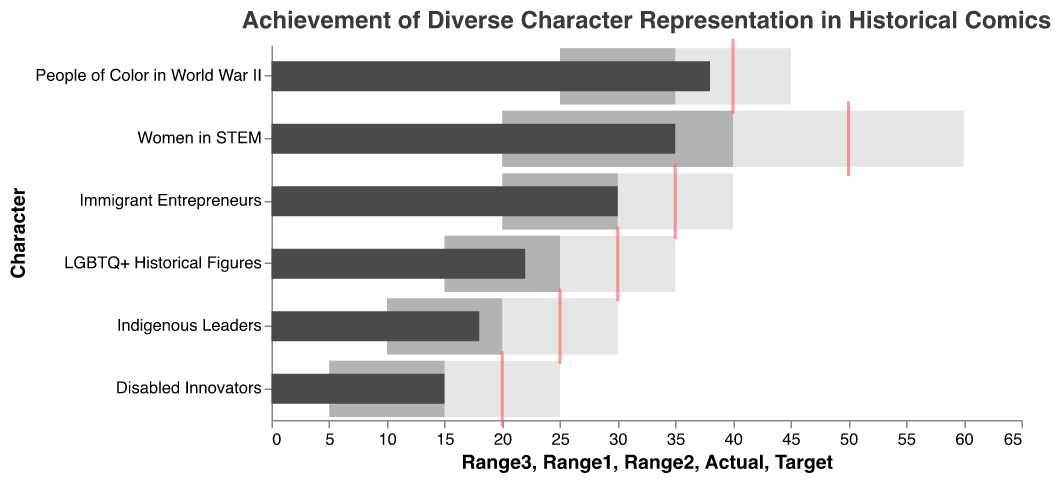What is the actual representation of 'Women in STEM' characters? The actual value for 'Women in STEM' can be seen in the bar marked dark gray. It shows a value of 35.
Answer: 35 How much lower is the actual representation of 'LGBTQ+ Historical Figures' compared to the target? The actual value for 'LGBTQ+ Historical Figures' is 22, while the target is 30. The difference is 30 - 22 = 8.
Answer: 8 Which character category meets its target closest? By looking at the bars and the tick marks for targets, 'People of Color in World War II' has the actual value of 38 very close to the target of 40, more so than the other categories.
Answer: People of Color in World War II What is the title of the chart? The title appears at the top of the chart and it reads: "Achievement of Diverse Character Representation in Historical Comics".
Answer: Achievement of Diverse Character Representation in Historical Comics Which character category has the lowest actual representation? The dark gray bar with the smallest value needs to be identified, which corresponds to 'Disabled Innovators' with an actual representation of 15.
Answer: Disabled Innovators What is the range 1 value of 'Indigenous Leaders'? The range 1 value for 'Indigenous Leaders' is listed in the data as 10.
Answer: 10 How does the actual representation of 'Immigrant Entrepreneurs' compare with its target? The actual value for 'Immigrant Entrepreneurs' is 30 while the target is 35. Since 30 is less than 35, it falls short of meeting its target.
Answer: Less than target Which two character categories have an actual representation of 30 or more? 'Women in STEM' has 35 and 'People of Color in World War II' has 38. Both 'Immigrant Entrepreneurs' also meets the criteria with an actual representation of 30. All these values can be visually identified from the chart.
Answer: Women in STEM, People of Color in World War II, Immigrant Entrepreneurs Are all actual values within the range 1-3 for each character? Check each character's actual values against their range 1 to range 3 values:
- 'Women in STEM': 35 (20-60) -> Yes
- 'LGBTQ+ Historical Figures': 22 (15-35) -> Yes
- 'People of Color in World War II': 38 (25-45) -> Yes
- 'Indigenous Leaders': 18 (10-30) -> Yes
- 'Disabled Innovators': 15 (5-25) -> Yes
- 'Immigrant Entrepreneurs': 30 (20-40) -> Yes
All actual values are within the respective ranges.
Answer: Yes 